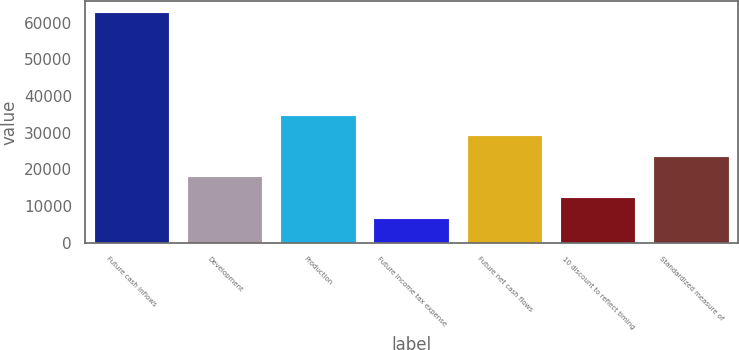<chart> <loc_0><loc_0><loc_500><loc_500><bar_chart><fcel>Future cash inflows<fcel>Development<fcel>Production<fcel>Future income tax expense<fcel>Future net cash flows<fcel>10 discount to reflect timing<fcel>Standardized measure of<nl><fcel>62743<fcel>17770.2<fcel>34635<fcel>6527<fcel>29013.4<fcel>12148.6<fcel>23391.8<nl></chart> 